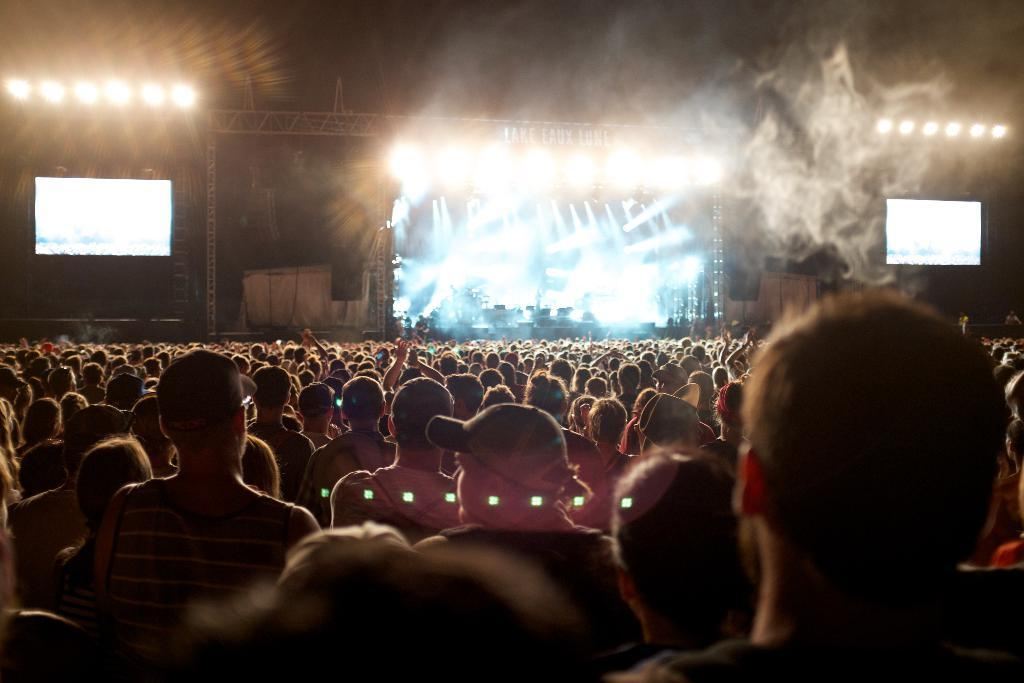What event is taking place in the image? It is a concert. What can be seen around the stage? There are lights around the stage. Are there any visual aids for the audience? Yes, there are two screens on either side of the stage. How many people are present at the concert? A huge crowd is standing in front of the dais. What type of muscle is being exercised by the governor in the image? There is no governor or any exercise activity present in the image. 